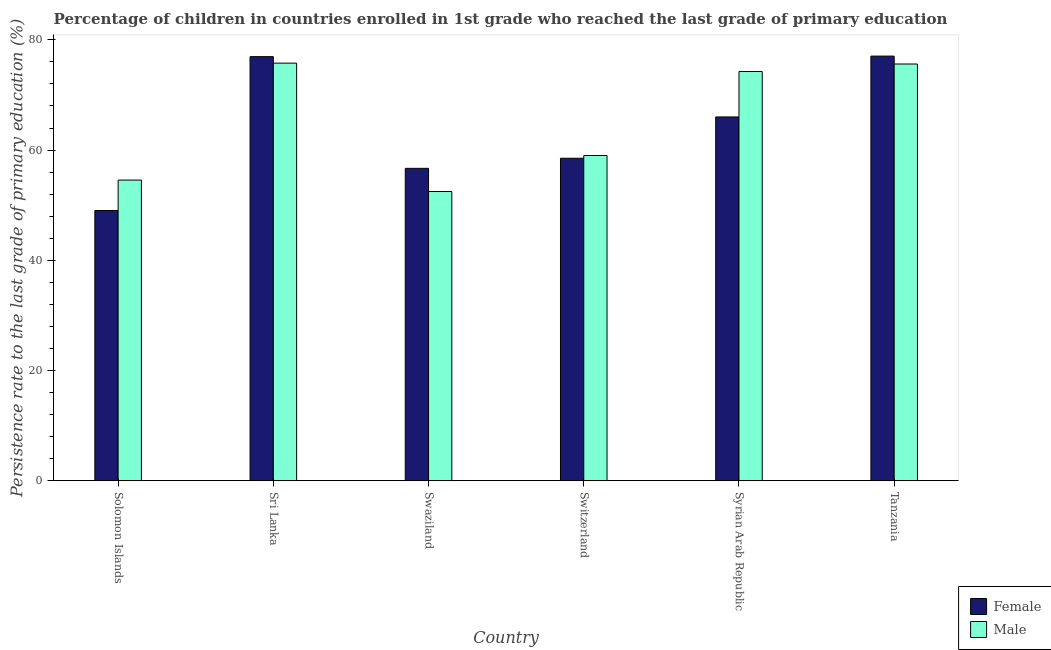Are the number of bars per tick equal to the number of legend labels?
Offer a terse response. Yes. Are the number of bars on each tick of the X-axis equal?
Ensure brevity in your answer.  Yes. How many bars are there on the 2nd tick from the left?
Provide a succinct answer. 2. What is the label of the 4th group of bars from the left?
Provide a short and direct response. Switzerland. What is the persistence rate of female students in Solomon Islands?
Your answer should be compact. 49.04. Across all countries, what is the maximum persistence rate of female students?
Offer a very short reply. 77.05. Across all countries, what is the minimum persistence rate of female students?
Offer a very short reply. 49.04. In which country was the persistence rate of male students maximum?
Offer a terse response. Sri Lanka. In which country was the persistence rate of male students minimum?
Keep it short and to the point. Swaziland. What is the total persistence rate of female students in the graph?
Give a very brief answer. 384.25. What is the difference between the persistence rate of female students in Swaziland and that in Switzerland?
Offer a very short reply. -1.83. What is the difference between the persistence rate of female students in Solomon Islands and the persistence rate of male students in Syrian Arab Republic?
Provide a short and direct response. -25.21. What is the average persistence rate of male students per country?
Give a very brief answer. 65.28. What is the difference between the persistence rate of female students and persistence rate of male students in Sri Lanka?
Your answer should be very brief. 1.18. What is the ratio of the persistence rate of male students in Sri Lanka to that in Syrian Arab Republic?
Offer a very short reply. 1.02. Is the persistence rate of female students in Swaziland less than that in Switzerland?
Keep it short and to the point. Yes. Is the difference between the persistence rate of female students in Sri Lanka and Tanzania greater than the difference between the persistence rate of male students in Sri Lanka and Tanzania?
Your response must be concise. No. What is the difference between the highest and the second highest persistence rate of male students?
Give a very brief answer. 0.16. What is the difference between the highest and the lowest persistence rate of male students?
Offer a terse response. 23.29. In how many countries, is the persistence rate of male students greater than the average persistence rate of male students taken over all countries?
Make the answer very short. 3. What does the 2nd bar from the left in Syrian Arab Republic represents?
Give a very brief answer. Male. What does the 2nd bar from the right in Syrian Arab Republic represents?
Provide a short and direct response. Female. How many countries are there in the graph?
Ensure brevity in your answer.  6. Are the values on the major ticks of Y-axis written in scientific E-notation?
Give a very brief answer. No. Where does the legend appear in the graph?
Your answer should be very brief. Bottom right. How many legend labels are there?
Make the answer very short. 2. How are the legend labels stacked?
Ensure brevity in your answer.  Vertical. What is the title of the graph?
Your answer should be very brief. Percentage of children in countries enrolled in 1st grade who reached the last grade of primary education. Does "GDP at market prices" appear as one of the legend labels in the graph?
Keep it short and to the point. No. What is the label or title of the X-axis?
Provide a short and direct response. Country. What is the label or title of the Y-axis?
Provide a short and direct response. Persistence rate to the last grade of primary education (%). What is the Persistence rate to the last grade of primary education (%) of Female in Solomon Islands?
Keep it short and to the point. 49.04. What is the Persistence rate to the last grade of primary education (%) of Male in Solomon Islands?
Make the answer very short. 54.55. What is the Persistence rate to the last grade of primary education (%) of Female in Sri Lanka?
Provide a short and direct response. 76.95. What is the Persistence rate to the last grade of primary education (%) of Male in Sri Lanka?
Give a very brief answer. 75.77. What is the Persistence rate to the last grade of primary education (%) of Female in Swaziland?
Provide a succinct answer. 56.69. What is the Persistence rate to the last grade of primary education (%) in Male in Swaziland?
Your answer should be compact. 52.48. What is the Persistence rate to the last grade of primary education (%) in Female in Switzerland?
Keep it short and to the point. 58.52. What is the Persistence rate to the last grade of primary education (%) in Male in Switzerland?
Your answer should be compact. 59.02. What is the Persistence rate to the last grade of primary education (%) of Female in Syrian Arab Republic?
Your answer should be very brief. 66.01. What is the Persistence rate to the last grade of primary education (%) of Male in Syrian Arab Republic?
Offer a terse response. 74.25. What is the Persistence rate to the last grade of primary education (%) of Female in Tanzania?
Ensure brevity in your answer.  77.05. What is the Persistence rate to the last grade of primary education (%) in Male in Tanzania?
Ensure brevity in your answer.  75.62. Across all countries, what is the maximum Persistence rate to the last grade of primary education (%) in Female?
Ensure brevity in your answer.  77.05. Across all countries, what is the maximum Persistence rate to the last grade of primary education (%) of Male?
Provide a succinct answer. 75.77. Across all countries, what is the minimum Persistence rate to the last grade of primary education (%) of Female?
Offer a terse response. 49.04. Across all countries, what is the minimum Persistence rate to the last grade of primary education (%) in Male?
Keep it short and to the point. 52.48. What is the total Persistence rate to the last grade of primary education (%) in Female in the graph?
Give a very brief answer. 384.25. What is the total Persistence rate to the last grade of primary education (%) of Male in the graph?
Your answer should be compact. 391.69. What is the difference between the Persistence rate to the last grade of primary education (%) of Female in Solomon Islands and that in Sri Lanka?
Provide a short and direct response. -27.91. What is the difference between the Persistence rate to the last grade of primary education (%) in Male in Solomon Islands and that in Sri Lanka?
Make the answer very short. -21.22. What is the difference between the Persistence rate to the last grade of primary education (%) in Female in Solomon Islands and that in Swaziland?
Give a very brief answer. -7.65. What is the difference between the Persistence rate to the last grade of primary education (%) of Male in Solomon Islands and that in Swaziland?
Your answer should be compact. 2.07. What is the difference between the Persistence rate to the last grade of primary education (%) in Female in Solomon Islands and that in Switzerland?
Provide a short and direct response. -9.48. What is the difference between the Persistence rate to the last grade of primary education (%) of Male in Solomon Islands and that in Switzerland?
Your answer should be very brief. -4.46. What is the difference between the Persistence rate to the last grade of primary education (%) in Female in Solomon Islands and that in Syrian Arab Republic?
Your answer should be compact. -16.97. What is the difference between the Persistence rate to the last grade of primary education (%) in Male in Solomon Islands and that in Syrian Arab Republic?
Offer a very short reply. -19.7. What is the difference between the Persistence rate to the last grade of primary education (%) in Female in Solomon Islands and that in Tanzania?
Keep it short and to the point. -28.01. What is the difference between the Persistence rate to the last grade of primary education (%) in Male in Solomon Islands and that in Tanzania?
Your response must be concise. -21.06. What is the difference between the Persistence rate to the last grade of primary education (%) of Female in Sri Lanka and that in Swaziland?
Your response must be concise. 20.26. What is the difference between the Persistence rate to the last grade of primary education (%) of Male in Sri Lanka and that in Swaziland?
Your answer should be compact. 23.29. What is the difference between the Persistence rate to the last grade of primary education (%) of Female in Sri Lanka and that in Switzerland?
Make the answer very short. 18.43. What is the difference between the Persistence rate to the last grade of primary education (%) of Male in Sri Lanka and that in Switzerland?
Give a very brief answer. 16.76. What is the difference between the Persistence rate to the last grade of primary education (%) of Female in Sri Lanka and that in Syrian Arab Republic?
Ensure brevity in your answer.  10.94. What is the difference between the Persistence rate to the last grade of primary education (%) in Male in Sri Lanka and that in Syrian Arab Republic?
Provide a short and direct response. 1.52. What is the difference between the Persistence rate to the last grade of primary education (%) in Female in Sri Lanka and that in Tanzania?
Give a very brief answer. -0.1. What is the difference between the Persistence rate to the last grade of primary education (%) of Male in Sri Lanka and that in Tanzania?
Offer a terse response. 0.16. What is the difference between the Persistence rate to the last grade of primary education (%) of Female in Swaziland and that in Switzerland?
Make the answer very short. -1.83. What is the difference between the Persistence rate to the last grade of primary education (%) in Male in Swaziland and that in Switzerland?
Keep it short and to the point. -6.53. What is the difference between the Persistence rate to the last grade of primary education (%) of Female in Swaziland and that in Syrian Arab Republic?
Give a very brief answer. -9.32. What is the difference between the Persistence rate to the last grade of primary education (%) in Male in Swaziland and that in Syrian Arab Republic?
Ensure brevity in your answer.  -21.77. What is the difference between the Persistence rate to the last grade of primary education (%) of Female in Swaziland and that in Tanzania?
Offer a terse response. -20.36. What is the difference between the Persistence rate to the last grade of primary education (%) in Male in Swaziland and that in Tanzania?
Your answer should be very brief. -23.13. What is the difference between the Persistence rate to the last grade of primary education (%) in Female in Switzerland and that in Syrian Arab Republic?
Give a very brief answer. -7.49. What is the difference between the Persistence rate to the last grade of primary education (%) of Male in Switzerland and that in Syrian Arab Republic?
Your answer should be very brief. -15.24. What is the difference between the Persistence rate to the last grade of primary education (%) in Female in Switzerland and that in Tanzania?
Give a very brief answer. -18.53. What is the difference between the Persistence rate to the last grade of primary education (%) of Male in Switzerland and that in Tanzania?
Provide a short and direct response. -16.6. What is the difference between the Persistence rate to the last grade of primary education (%) in Female in Syrian Arab Republic and that in Tanzania?
Make the answer very short. -11.04. What is the difference between the Persistence rate to the last grade of primary education (%) of Male in Syrian Arab Republic and that in Tanzania?
Your response must be concise. -1.36. What is the difference between the Persistence rate to the last grade of primary education (%) of Female in Solomon Islands and the Persistence rate to the last grade of primary education (%) of Male in Sri Lanka?
Provide a short and direct response. -26.73. What is the difference between the Persistence rate to the last grade of primary education (%) in Female in Solomon Islands and the Persistence rate to the last grade of primary education (%) in Male in Swaziland?
Keep it short and to the point. -3.44. What is the difference between the Persistence rate to the last grade of primary education (%) in Female in Solomon Islands and the Persistence rate to the last grade of primary education (%) in Male in Switzerland?
Your response must be concise. -9.98. What is the difference between the Persistence rate to the last grade of primary education (%) in Female in Solomon Islands and the Persistence rate to the last grade of primary education (%) in Male in Syrian Arab Republic?
Your answer should be very brief. -25.21. What is the difference between the Persistence rate to the last grade of primary education (%) of Female in Solomon Islands and the Persistence rate to the last grade of primary education (%) of Male in Tanzania?
Your response must be concise. -26.58. What is the difference between the Persistence rate to the last grade of primary education (%) of Female in Sri Lanka and the Persistence rate to the last grade of primary education (%) of Male in Swaziland?
Keep it short and to the point. 24.47. What is the difference between the Persistence rate to the last grade of primary education (%) of Female in Sri Lanka and the Persistence rate to the last grade of primary education (%) of Male in Switzerland?
Your response must be concise. 17.93. What is the difference between the Persistence rate to the last grade of primary education (%) in Female in Sri Lanka and the Persistence rate to the last grade of primary education (%) in Male in Syrian Arab Republic?
Give a very brief answer. 2.7. What is the difference between the Persistence rate to the last grade of primary education (%) in Female in Sri Lanka and the Persistence rate to the last grade of primary education (%) in Male in Tanzania?
Your response must be concise. 1.33. What is the difference between the Persistence rate to the last grade of primary education (%) of Female in Swaziland and the Persistence rate to the last grade of primary education (%) of Male in Switzerland?
Provide a short and direct response. -2.33. What is the difference between the Persistence rate to the last grade of primary education (%) in Female in Swaziland and the Persistence rate to the last grade of primary education (%) in Male in Syrian Arab Republic?
Keep it short and to the point. -17.56. What is the difference between the Persistence rate to the last grade of primary education (%) in Female in Swaziland and the Persistence rate to the last grade of primary education (%) in Male in Tanzania?
Make the answer very short. -18.93. What is the difference between the Persistence rate to the last grade of primary education (%) in Female in Switzerland and the Persistence rate to the last grade of primary education (%) in Male in Syrian Arab Republic?
Your answer should be very brief. -15.73. What is the difference between the Persistence rate to the last grade of primary education (%) of Female in Switzerland and the Persistence rate to the last grade of primary education (%) of Male in Tanzania?
Your answer should be very brief. -17.1. What is the difference between the Persistence rate to the last grade of primary education (%) in Female in Syrian Arab Republic and the Persistence rate to the last grade of primary education (%) in Male in Tanzania?
Provide a succinct answer. -9.61. What is the average Persistence rate to the last grade of primary education (%) in Female per country?
Give a very brief answer. 64.04. What is the average Persistence rate to the last grade of primary education (%) in Male per country?
Keep it short and to the point. 65.28. What is the difference between the Persistence rate to the last grade of primary education (%) of Female and Persistence rate to the last grade of primary education (%) of Male in Solomon Islands?
Your answer should be compact. -5.52. What is the difference between the Persistence rate to the last grade of primary education (%) in Female and Persistence rate to the last grade of primary education (%) in Male in Sri Lanka?
Your response must be concise. 1.18. What is the difference between the Persistence rate to the last grade of primary education (%) in Female and Persistence rate to the last grade of primary education (%) in Male in Swaziland?
Your response must be concise. 4.21. What is the difference between the Persistence rate to the last grade of primary education (%) in Female and Persistence rate to the last grade of primary education (%) in Male in Switzerland?
Give a very brief answer. -0.5. What is the difference between the Persistence rate to the last grade of primary education (%) in Female and Persistence rate to the last grade of primary education (%) in Male in Syrian Arab Republic?
Your answer should be very brief. -8.24. What is the difference between the Persistence rate to the last grade of primary education (%) in Female and Persistence rate to the last grade of primary education (%) in Male in Tanzania?
Give a very brief answer. 1.43. What is the ratio of the Persistence rate to the last grade of primary education (%) of Female in Solomon Islands to that in Sri Lanka?
Offer a very short reply. 0.64. What is the ratio of the Persistence rate to the last grade of primary education (%) of Male in Solomon Islands to that in Sri Lanka?
Offer a very short reply. 0.72. What is the ratio of the Persistence rate to the last grade of primary education (%) of Female in Solomon Islands to that in Swaziland?
Your response must be concise. 0.87. What is the ratio of the Persistence rate to the last grade of primary education (%) in Male in Solomon Islands to that in Swaziland?
Ensure brevity in your answer.  1.04. What is the ratio of the Persistence rate to the last grade of primary education (%) in Female in Solomon Islands to that in Switzerland?
Keep it short and to the point. 0.84. What is the ratio of the Persistence rate to the last grade of primary education (%) of Male in Solomon Islands to that in Switzerland?
Your response must be concise. 0.92. What is the ratio of the Persistence rate to the last grade of primary education (%) of Female in Solomon Islands to that in Syrian Arab Republic?
Offer a terse response. 0.74. What is the ratio of the Persistence rate to the last grade of primary education (%) in Male in Solomon Islands to that in Syrian Arab Republic?
Ensure brevity in your answer.  0.73. What is the ratio of the Persistence rate to the last grade of primary education (%) in Female in Solomon Islands to that in Tanzania?
Keep it short and to the point. 0.64. What is the ratio of the Persistence rate to the last grade of primary education (%) of Male in Solomon Islands to that in Tanzania?
Offer a terse response. 0.72. What is the ratio of the Persistence rate to the last grade of primary education (%) in Female in Sri Lanka to that in Swaziland?
Ensure brevity in your answer.  1.36. What is the ratio of the Persistence rate to the last grade of primary education (%) in Male in Sri Lanka to that in Swaziland?
Your answer should be very brief. 1.44. What is the ratio of the Persistence rate to the last grade of primary education (%) in Female in Sri Lanka to that in Switzerland?
Your response must be concise. 1.31. What is the ratio of the Persistence rate to the last grade of primary education (%) in Male in Sri Lanka to that in Switzerland?
Your answer should be very brief. 1.28. What is the ratio of the Persistence rate to the last grade of primary education (%) in Female in Sri Lanka to that in Syrian Arab Republic?
Provide a short and direct response. 1.17. What is the ratio of the Persistence rate to the last grade of primary education (%) in Male in Sri Lanka to that in Syrian Arab Republic?
Your response must be concise. 1.02. What is the ratio of the Persistence rate to the last grade of primary education (%) of Male in Sri Lanka to that in Tanzania?
Make the answer very short. 1. What is the ratio of the Persistence rate to the last grade of primary education (%) of Female in Swaziland to that in Switzerland?
Your response must be concise. 0.97. What is the ratio of the Persistence rate to the last grade of primary education (%) of Male in Swaziland to that in Switzerland?
Your answer should be compact. 0.89. What is the ratio of the Persistence rate to the last grade of primary education (%) of Female in Swaziland to that in Syrian Arab Republic?
Provide a short and direct response. 0.86. What is the ratio of the Persistence rate to the last grade of primary education (%) in Male in Swaziland to that in Syrian Arab Republic?
Ensure brevity in your answer.  0.71. What is the ratio of the Persistence rate to the last grade of primary education (%) of Female in Swaziland to that in Tanzania?
Give a very brief answer. 0.74. What is the ratio of the Persistence rate to the last grade of primary education (%) of Male in Swaziland to that in Tanzania?
Offer a very short reply. 0.69. What is the ratio of the Persistence rate to the last grade of primary education (%) in Female in Switzerland to that in Syrian Arab Republic?
Provide a succinct answer. 0.89. What is the ratio of the Persistence rate to the last grade of primary education (%) in Male in Switzerland to that in Syrian Arab Republic?
Provide a succinct answer. 0.79. What is the ratio of the Persistence rate to the last grade of primary education (%) of Female in Switzerland to that in Tanzania?
Your response must be concise. 0.76. What is the ratio of the Persistence rate to the last grade of primary education (%) in Male in Switzerland to that in Tanzania?
Provide a short and direct response. 0.78. What is the ratio of the Persistence rate to the last grade of primary education (%) of Female in Syrian Arab Republic to that in Tanzania?
Make the answer very short. 0.86. What is the difference between the highest and the second highest Persistence rate to the last grade of primary education (%) in Female?
Offer a terse response. 0.1. What is the difference between the highest and the second highest Persistence rate to the last grade of primary education (%) of Male?
Make the answer very short. 0.16. What is the difference between the highest and the lowest Persistence rate to the last grade of primary education (%) of Female?
Offer a very short reply. 28.01. What is the difference between the highest and the lowest Persistence rate to the last grade of primary education (%) in Male?
Provide a succinct answer. 23.29. 